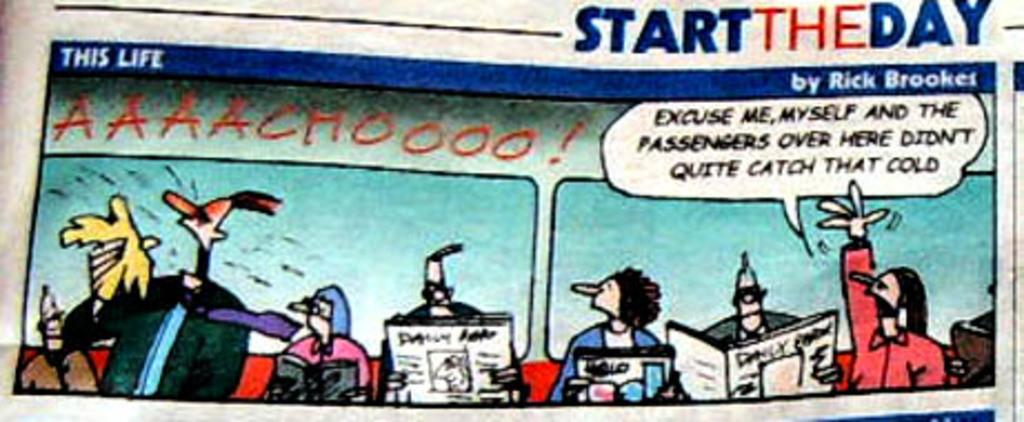Provide a one-sentence caption for the provided image. A cartoon from STARTTHEDAY features a man reading a newspaper. 